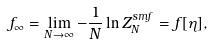Convert formula to latex. <formula><loc_0><loc_0><loc_500><loc_500>f _ { \infty } = \lim _ { N \rightarrow \infty } - \frac { 1 } { N } \ln Z _ { N } ^ { s m f } = f [ \eta ] ,</formula> 